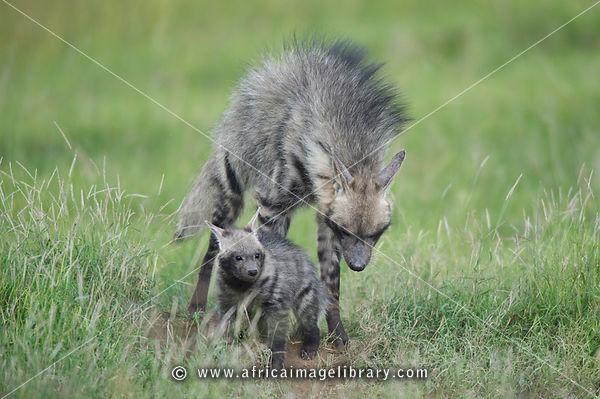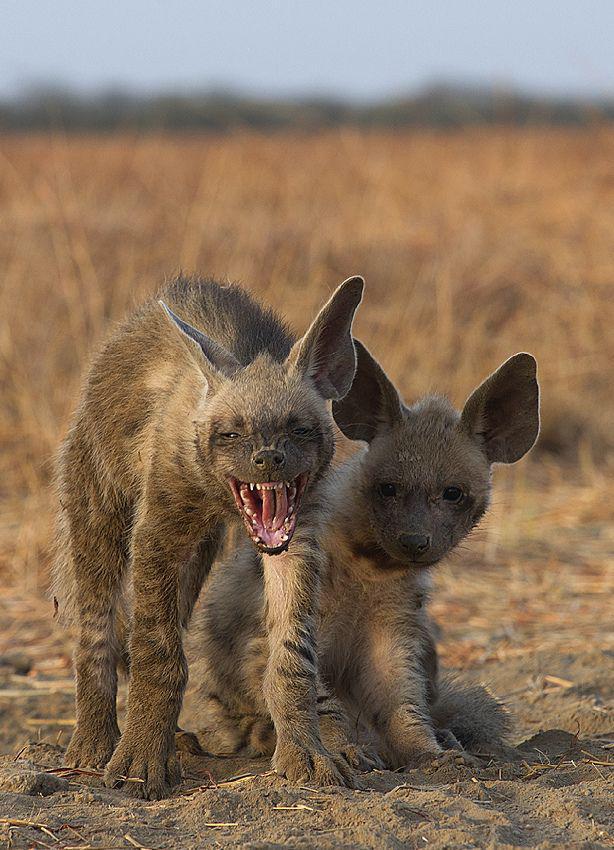The first image is the image on the left, the second image is the image on the right. Analyze the images presented: Is the assertion "In the left image, we have a mother and her pups." valid? Answer yes or no. Yes. The first image is the image on the left, the second image is the image on the right. Analyze the images presented: Is the assertion "The right image contains at least two hyenas." valid? Answer yes or no. Yes. 